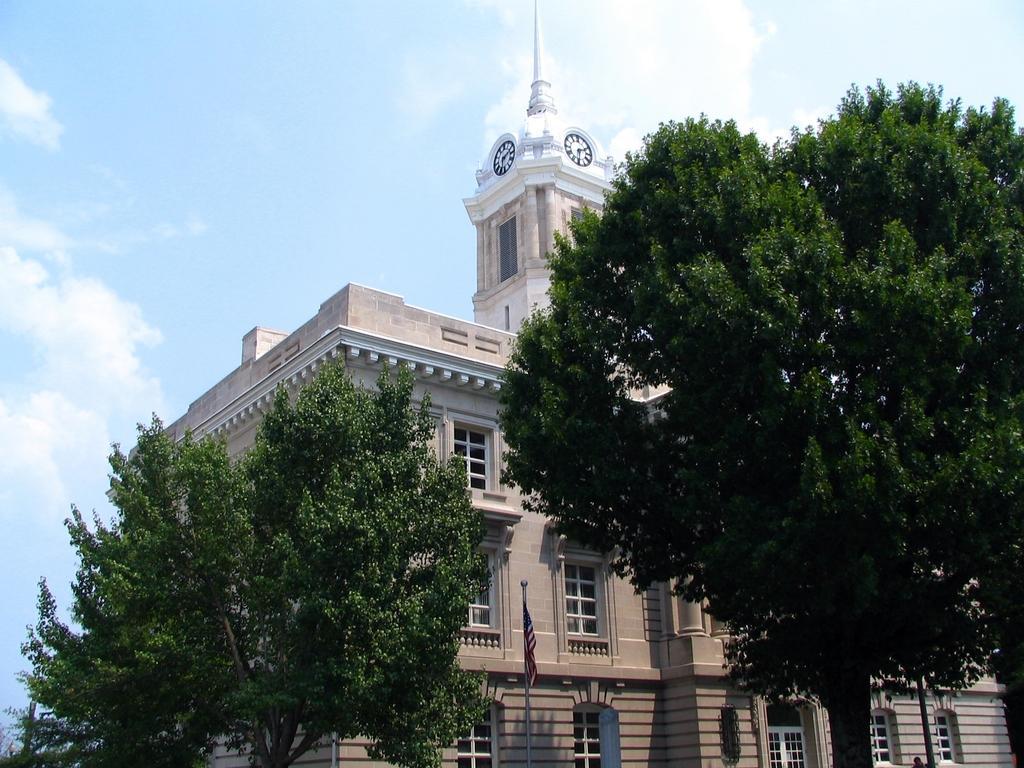Can you describe this image briefly? As we can see in the image there are trees, buildings, flag, windows, sky and clouds. 